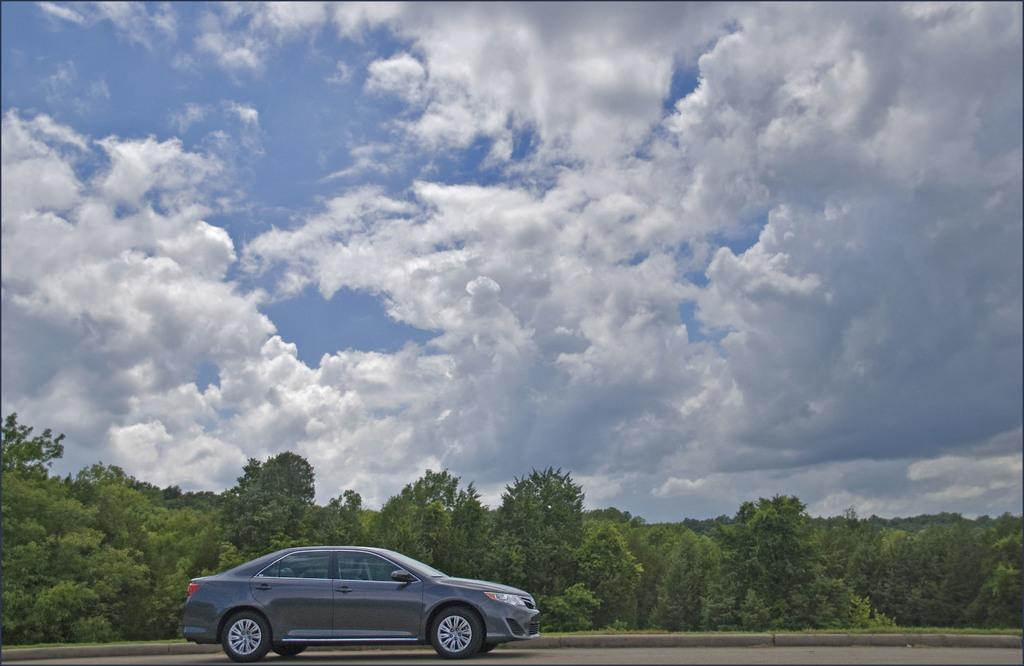What is visible at the top of the image? The sky is visible at the top of the image. What can be seen in the middle of the image? There are trees in the middle of the image. What type of transportation is visible at the bottom of the image? A vehicle is visible on the road at the bottom of the image. Can you see a zephyr flying through the trees in the image? There is no mention of a zephyr in the image, and it is not a visible object. A zephyr is a gentle breeze, not an object that can be seen. 